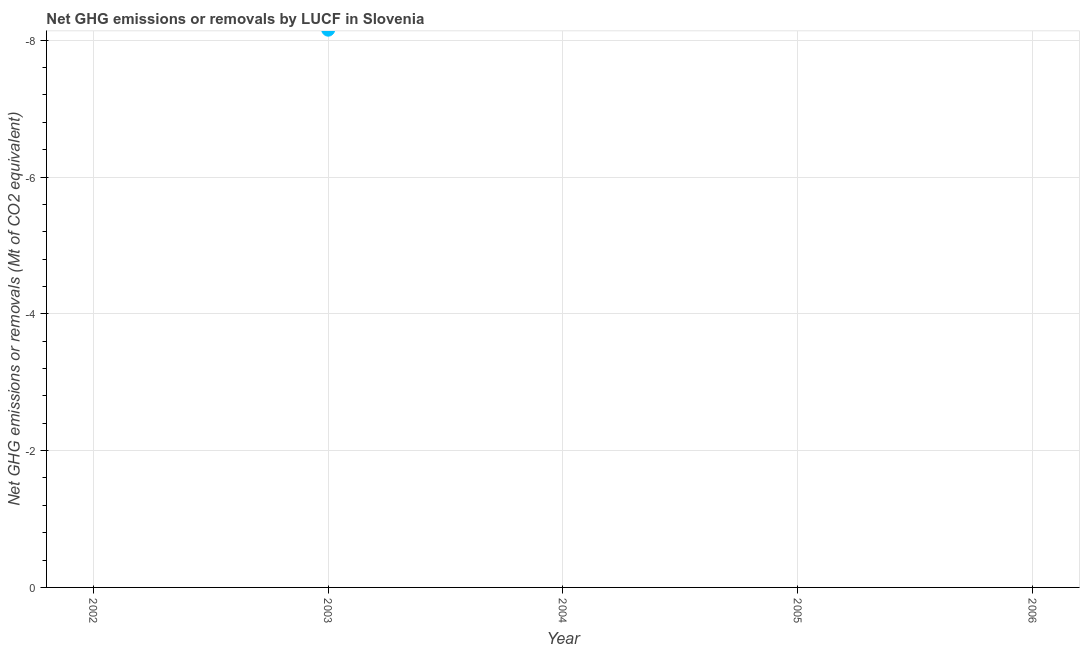Across all years, what is the minimum ghg net emissions or removals?
Your answer should be compact. 0. In how many years, is the ghg net emissions or removals greater than -7.2 Mt?
Your answer should be very brief. 0. Does the graph contain grids?
Make the answer very short. Yes. What is the title of the graph?
Ensure brevity in your answer.  Net GHG emissions or removals by LUCF in Slovenia. What is the label or title of the Y-axis?
Give a very brief answer. Net GHG emissions or removals (Mt of CO2 equivalent). What is the Net GHG emissions or removals (Mt of CO2 equivalent) in 2002?
Your answer should be compact. 0. What is the Net GHG emissions or removals (Mt of CO2 equivalent) in 2004?
Make the answer very short. 0. 